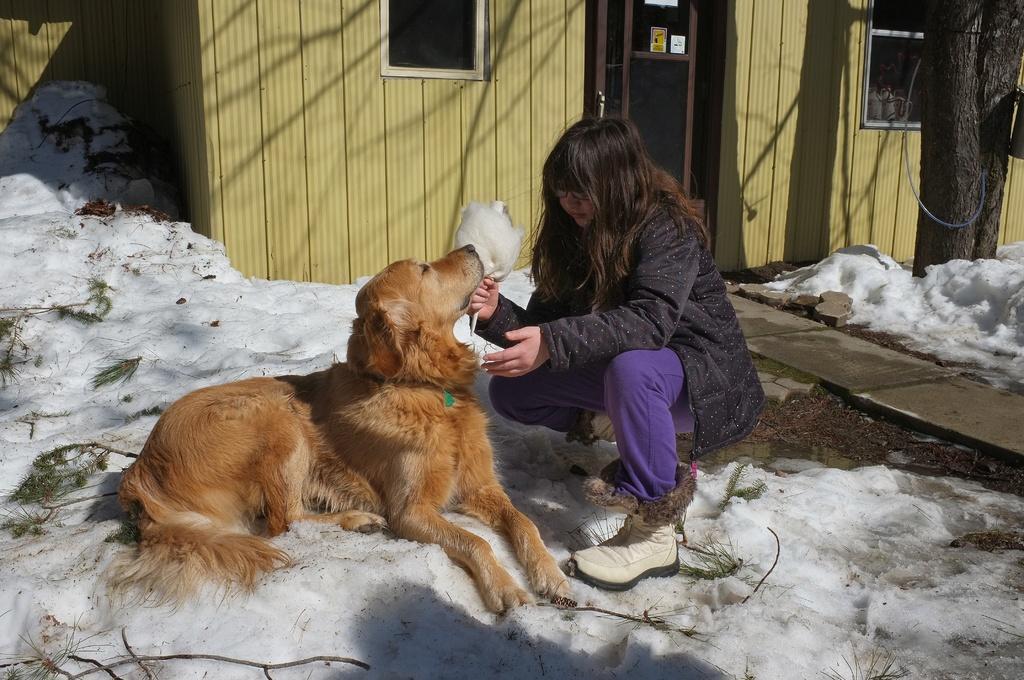Could you give a brief overview of what you see in this image? This is a girl sitting in squat position and playing with a dog. I think this is a snow. This looks like a small shelter with window. This is a door with a door handle. I can see tree trunk. This is the pathway to enter into the house. 